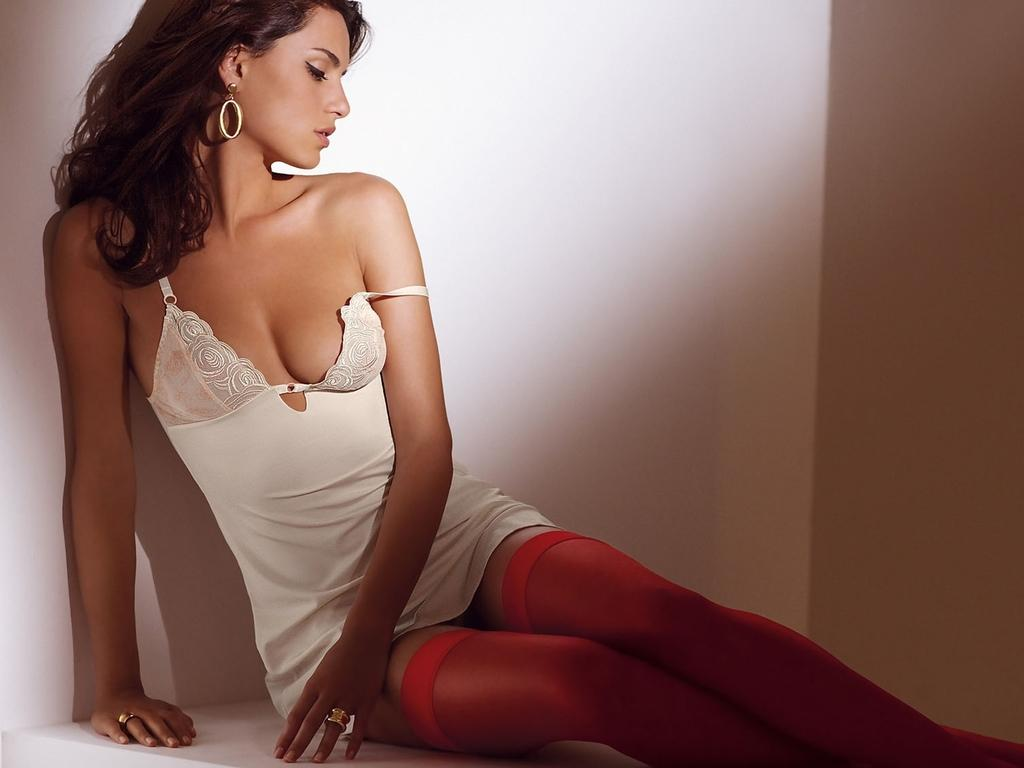What is the main subject of the image? There is a lady sitting in the center of the image. What is the lady wearing on her feet? The lady is wearing socks. What can be seen in the background of the image? There is a wall in the background of the image. How many boats are visible in the image? There are no boats present in the image; it features a lady sitting and wearing socks with a wall in the background. 